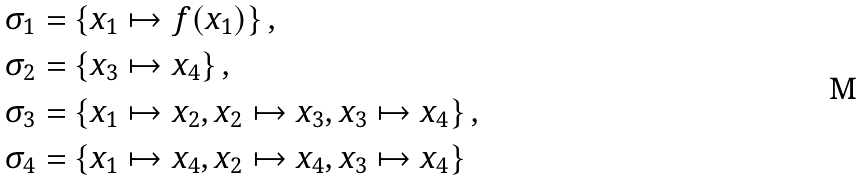<formula> <loc_0><loc_0><loc_500><loc_500>\sigma _ { 1 } & = \left \{ x _ { 1 } \mapsto f ( x _ { 1 } ) \right \} , \\ \sigma _ { 2 } & = \left \{ x _ { 3 } \mapsto x _ { 4 } \right \} , \\ \sigma _ { 3 } & = \left \{ x _ { 1 } \mapsto x _ { 2 } , x _ { 2 } \mapsto x _ { 3 } , x _ { 3 } \mapsto x _ { 4 } \right \} , \\ \sigma _ { 4 } & = \left \{ x _ { 1 } \mapsto x _ { 4 } , x _ { 2 } \mapsto x _ { 4 } , x _ { 3 } \mapsto x _ { 4 } \right \}</formula> 